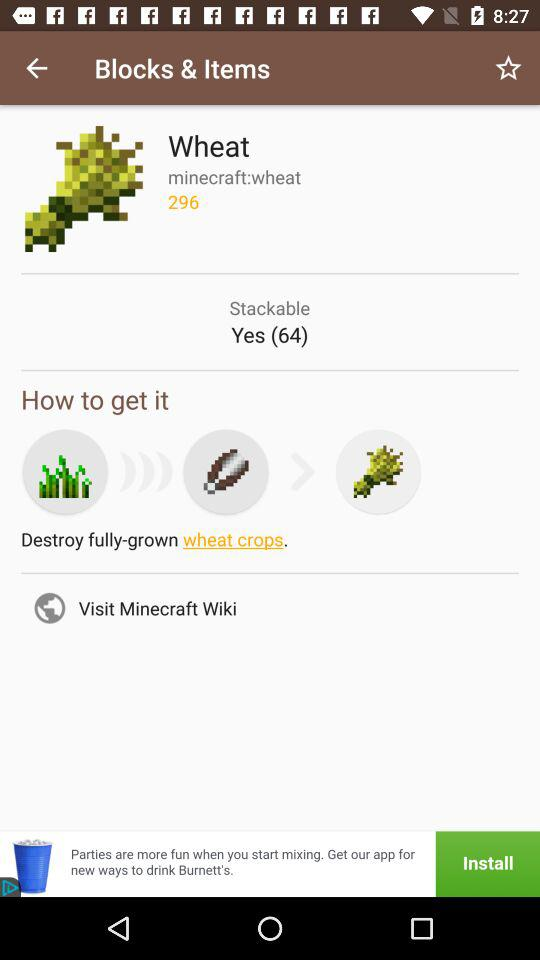What is the numerical ID of "Wheat"? The numerical ID of "Wheat" is 296. 